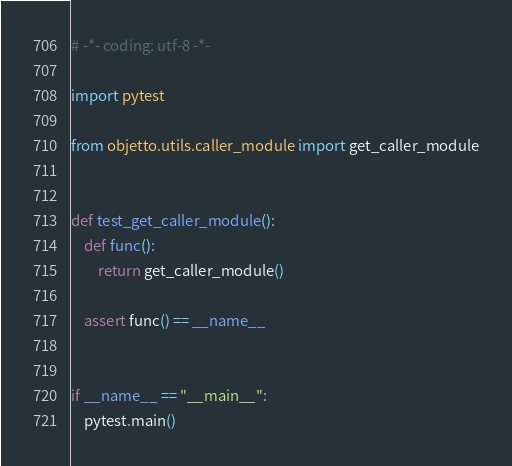<code> <loc_0><loc_0><loc_500><loc_500><_Python_># -*- coding: utf-8 -*-

import pytest

from objetto.utils.caller_module import get_caller_module


def test_get_caller_module():
    def func():
        return get_caller_module()

    assert func() == __name__


if __name__ == "__main__":
    pytest.main()
</code> 